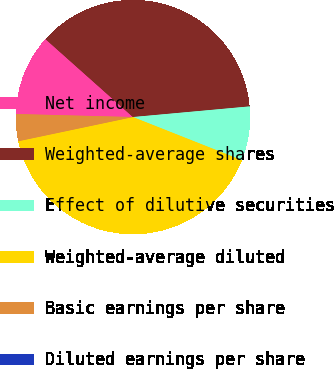Convert chart. <chart><loc_0><loc_0><loc_500><loc_500><pie_chart><fcel>Net income<fcel>Weighted-average shares<fcel>Effect of dilutive securities<fcel>Weighted-average diluted<fcel>Basic earnings per share<fcel>Diluted earnings per share<nl><fcel>11.17%<fcel>36.97%<fcel>7.45%<fcel>40.69%<fcel>3.72%<fcel>0.0%<nl></chart> 